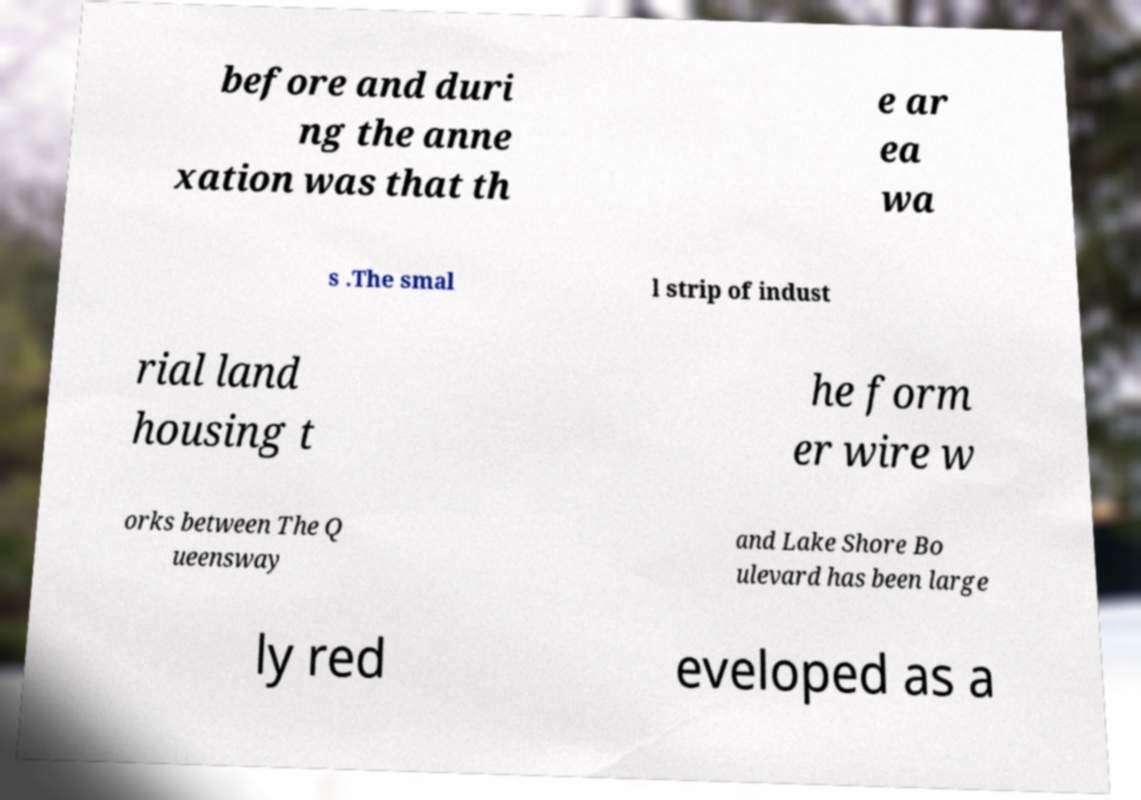What messages or text are displayed in this image? I need them in a readable, typed format. before and duri ng the anne xation was that th e ar ea wa s .The smal l strip of indust rial land housing t he form er wire w orks between The Q ueensway and Lake Shore Bo ulevard has been large ly red eveloped as a 